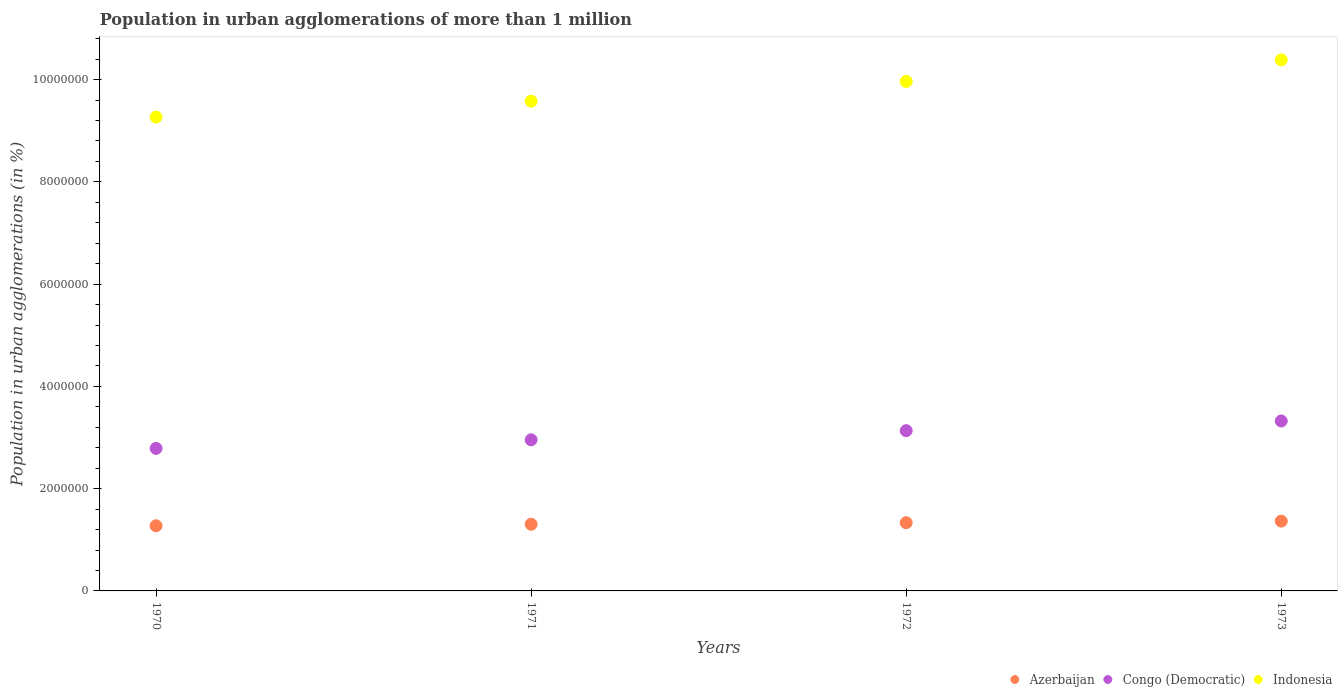What is the population in urban agglomerations in Congo (Democratic) in 1970?
Offer a terse response. 2.79e+06. Across all years, what is the maximum population in urban agglomerations in Indonesia?
Provide a short and direct response. 1.04e+07. Across all years, what is the minimum population in urban agglomerations in Congo (Democratic)?
Offer a very short reply. 2.79e+06. In which year was the population in urban agglomerations in Indonesia minimum?
Your response must be concise. 1970. What is the total population in urban agglomerations in Indonesia in the graph?
Ensure brevity in your answer.  3.92e+07. What is the difference between the population in urban agglomerations in Azerbaijan in 1971 and that in 1973?
Offer a terse response. -6.12e+04. What is the difference between the population in urban agglomerations in Congo (Democratic) in 1973 and the population in urban agglomerations in Indonesia in 1972?
Provide a short and direct response. -6.64e+06. What is the average population in urban agglomerations in Azerbaijan per year?
Offer a very short reply. 1.32e+06. In the year 1970, what is the difference between the population in urban agglomerations in Congo (Democratic) and population in urban agglomerations in Indonesia?
Keep it short and to the point. -6.48e+06. What is the ratio of the population in urban agglomerations in Azerbaijan in 1970 to that in 1973?
Your response must be concise. 0.93. Is the population in urban agglomerations in Azerbaijan in 1971 less than that in 1973?
Offer a very short reply. Yes. Is the difference between the population in urban agglomerations in Congo (Democratic) in 1971 and 1973 greater than the difference between the population in urban agglomerations in Indonesia in 1971 and 1973?
Your answer should be very brief. Yes. What is the difference between the highest and the second highest population in urban agglomerations in Indonesia?
Your response must be concise. 4.23e+05. What is the difference between the highest and the lowest population in urban agglomerations in Congo (Democratic)?
Make the answer very short. 5.36e+05. In how many years, is the population in urban agglomerations in Congo (Democratic) greater than the average population in urban agglomerations in Congo (Democratic) taken over all years?
Make the answer very short. 2. Is the sum of the population in urban agglomerations in Congo (Democratic) in 1971 and 1972 greater than the maximum population in urban agglomerations in Indonesia across all years?
Your answer should be very brief. No. Is it the case that in every year, the sum of the population in urban agglomerations in Azerbaijan and population in urban agglomerations in Indonesia  is greater than the population in urban agglomerations in Congo (Democratic)?
Your response must be concise. Yes. Does the population in urban agglomerations in Azerbaijan monotonically increase over the years?
Provide a short and direct response. Yes. How many dotlines are there?
Your response must be concise. 3. What is the difference between two consecutive major ticks on the Y-axis?
Make the answer very short. 2.00e+06. Does the graph contain grids?
Provide a succinct answer. No. How many legend labels are there?
Offer a very short reply. 3. How are the legend labels stacked?
Offer a very short reply. Horizontal. What is the title of the graph?
Your response must be concise. Population in urban agglomerations of more than 1 million. Does "Barbados" appear as one of the legend labels in the graph?
Ensure brevity in your answer.  No. What is the label or title of the Y-axis?
Your answer should be very brief. Population in urban agglomerations (in %). What is the Population in urban agglomerations (in %) of Azerbaijan in 1970?
Offer a terse response. 1.27e+06. What is the Population in urban agglomerations (in %) of Congo (Democratic) in 1970?
Offer a terse response. 2.79e+06. What is the Population in urban agglomerations (in %) in Indonesia in 1970?
Ensure brevity in your answer.  9.27e+06. What is the Population in urban agglomerations (in %) in Azerbaijan in 1971?
Offer a very short reply. 1.30e+06. What is the Population in urban agglomerations (in %) in Congo (Democratic) in 1971?
Offer a terse response. 2.96e+06. What is the Population in urban agglomerations (in %) of Indonesia in 1971?
Offer a very short reply. 9.58e+06. What is the Population in urban agglomerations (in %) of Azerbaijan in 1972?
Your answer should be very brief. 1.33e+06. What is the Population in urban agglomerations (in %) of Congo (Democratic) in 1972?
Your answer should be compact. 3.13e+06. What is the Population in urban agglomerations (in %) of Indonesia in 1972?
Make the answer very short. 9.96e+06. What is the Population in urban agglomerations (in %) of Azerbaijan in 1973?
Your answer should be very brief. 1.37e+06. What is the Population in urban agglomerations (in %) of Congo (Democratic) in 1973?
Offer a terse response. 3.32e+06. What is the Population in urban agglomerations (in %) in Indonesia in 1973?
Your answer should be very brief. 1.04e+07. Across all years, what is the maximum Population in urban agglomerations (in %) in Azerbaijan?
Provide a succinct answer. 1.37e+06. Across all years, what is the maximum Population in urban agglomerations (in %) of Congo (Democratic)?
Make the answer very short. 3.32e+06. Across all years, what is the maximum Population in urban agglomerations (in %) in Indonesia?
Offer a very short reply. 1.04e+07. Across all years, what is the minimum Population in urban agglomerations (in %) in Azerbaijan?
Give a very brief answer. 1.27e+06. Across all years, what is the minimum Population in urban agglomerations (in %) of Congo (Democratic)?
Give a very brief answer. 2.79e+06. Across all years, what is the minimum Population in urban agglomerations (in %) in Indonesia?
Offer a very short reply. 9.27e+06. What is the total Population in urban agglomerations (in %) in Azerbaijan in the graph?
Your answer should be compact. 5.28e+06. What is the total Population in urban agglomerations (in %) in Congo (Democratic) in the graph?
Your answer should be very brief. 1.22e+07. What is the total Population in urban agglomerations (in %) of Indonesia in the graph?
Your response must be concise. 3.92e+07. What is the difference between the Population in urban agglomerations (in %) of Azerbaijan in 1970 and that in 1971?
Offer a terse response. -2.96e+04. What is the difference between the Population in urban agglomerations (in %) of Congo (Democratic) in 1970 and that in 1971?
Keep it short and to the point. -1.68e+05. What is the difference between the Population in urban agglomerations (in %) in Indonesia in 1970 and that in 1971?
Offer a very short reply. -3.10e+05. What is the difference between the Population in urban agglomerations (in %) in Azerbaijan in 1970 and that in 1972?
Provide a succinct answer. -5.98e+04. What is the difference between the Population in urban agglomerations (in %) in Congo (Democratic) in 1970 and that in 1972?
Keep it short and to the point. -3.47e+05. What is the difference between the Population in urban agglomerations (in %) of Indonesia in 1970 and that in 1972?
Provide a succinct answer. -6.96e+05. What is the difference between the Population in urban agglomerations (in %) of Azerbaijan in 1970 and that in 1973?
Your response must be concise. -9.07e+04. What is the difference between the Population in urban agglomerations (in %) in Congo (Democratic) in 1970 and that in 1973?
Keep it short and to the point. -5.36e+05. What is the difference between the Population in urban agglomerations (in %) in Indonesia in 1970 and that in 1973?
Give a very brief answer. -1.12e+06. What is the difference between the Population in urban agglomerations (in %) in Azerbaijan in 1971 and that in 1972?
Offer a terse response. -3.03e+04. What is the difference between the Population in urban agglomerations (in %) in Congo (Democratic) in 1971 and that in 1972?
Your response must be concise. -1.79e+05. What is the difference between the Population in urban agglomerations (in %) of Indonesia in 1971 and that in 1972?
Your response must be concise. -3.86e+05. What is the difference between the Population in urban agglomerations (in %) of Azerbaijan in 1971 and that in 1973?
Ensure brevity in your answer.  -6.12e+04. What is the difference between the Population in urban agglomerations (in %) in Congo (Democratic) in 1971 and that in 1973?
Keep it short and to the point. -3.68e+05. What is the difference between the Population in urban agglomerations (in %) in Indonesia in 1971 and that in 1973?
Offer a terse response. -8.09e+05. What is the difference between the Population in urban agglomerations (in %) of Azerbaijan in 1972 and that in 1973?
Give a very brief answer. -3.09e+04. What is the difference between the Population in urban agglomerations (in %) in Congo (Democratic) in 1972 and that in 1973?
Your answer should be compact. -1.89e+05. What is the difference between the Population in urban agglomerations (in %) in Indonesia in 1972 and that in 1973?
Offer a very short reply. -4.23e+05. What is the difference between the Population in urban agglomerations (in %) of Azerbaijan in 1970 and the Population in urban agglomerations (in %) of Congo (Democratic) in 1971?
Offer a terse response. -1.68e+06. What is the difference between the Population in urban agglomerations (in %) in Azerbaijan in 1970 and the Population in urban agglomerations (in %) in Indonesia in 1971?
Provide a short and direct response. -8.30e+06. What is the difference between the Population in urban agglomerations (in %) in Congo (Democratic) in 1970 and the Population in urban agglomerations (in %) in Indonesia in 1971?
Provide a short and direct response. -6.79e+06. What is the difference between the Population in urban agglomerations (in %) in Azerbaijan in 1970 and the Population in urban agglomerations (in %) in Congo (Democratic) in 1972?
Offer a terse response. -1.86e+06. What is the difference between the Population in urban agglomerations (in %) of Azerbaijan in 1970 and the Population in urban agglomerations (in %) of Indonesia in 1972?
Give a very brief answer. -8.69e+06. What is the difference between the Population in urban agglomerations (in %) of Congo (Democratic) in 1970 and the Population in urban agglomerations (in %) of Indonesia in 1972?
Offer a very short reply. -7.18e+06. What is the difference between the Population in urban agglomerations (in %) in Azerbaijan in 1970 and the Population in urban agglomerations (in %) in Congo (Democratic) in 1973?
Provide a succinct answer. -2.05e+06. What is the difference between the Population in urban agglomerations (in %) of Azerbaijan in 1970 and the Population in urban agglomerations (in %) of Indonesia in 1973?
Offer a very short reply. -9.11e+06. What is the difference between the Population in urban agglomerations (in %) of Congo (Democratic) in 1970 and the Population in urban agglomerations (in %) of Indonesia in 1973?
Offer a terse response. -7.60e+06. What is the difference between the Population in urban agglomerations (in %) of Azerbaijan in 1971 and the Population in urban agglomerations (in %) of Congo (Democratic) in 1972?
Offer a terse response. -1.83e+06. What is the difference between the Population in urban agglomerations (in %) in Azerbaijan in 1971 and the Population in urban agglomerations (in %) in Indonesia in 1972?
Ensure brevity in your answer.  -8.66e+06. What is the difference between the Population in urban agglomerations (in %) of Congo (Democratic) in 1971 and the Population in urban agglomerations (in %) of Indonesia in 1972?
Provide a short and direct response. -7.01e+06. What is the difference between the Population in urban agglomerations (in %) in Azerbaijan in 1971 and the Population in urban agglomerations (in %) in Congo (Democratic) in 1973?
Give a very brief answer. -2.02e+06. What is the difference between the Population in urban agglomerations (in %) in Azerbaijan in 1971 and the Population in urban agglomerations (in %) in Indonesia in 1973?
Keep it short and to the point. -9.08e+06. What is the difference between the Population in urban agglomerations (in %) of Congo (Democratic) in 1971 and the Population in urban agglomerations (in %) of Indonesia in 1973?
Provide a short and direct response. -7.43e+06. What is the difference between the Population in urban agglomerations (in %) of Azerbaijan in 1972 and the Population in urban agglomerations (in %) of Congo (Democratic) in 1973?
Your answer should be compact. -1.99e+06. What is the difference between the Population in urban agglomerations (in %) of Azerbaijan in 1972 and the Population in urban agglomerations (in %) of Indonesia in 1973?
Keep it short and to the point. -9.05e+06. What is the difference between the Population in urban agglomerations (in %) of Congo (Democratic) in 1972 and the Population in urban agglomerations (in %) of Indonesia in 1973?
Make the answer very short. -7.25e+06. What is the average Population in urban agglomerations (in %) in Azerbaijan per year?
Provide a succinct answer. 1.32e+06. What is the average Population in urban agglomerations (in %) in Congo (Democratic) per year?
Make the answer very short. 3.05e+06. What is the average Population in urban agglomerations (in %) of Indonesia per year?
Your answer should be very brief. 9.80e+06. In the year 1970, what is the difference between the Population in urban agglomerations (in %) of Azerbaijan and Population in urban agglomerations (in %) of Congo (Democratic)?
Give a very brief answer. -1.51e+06. In the year 1970, what is the difference between the Population in urban agglomerations (in %) of Azerbaijan and Population in urban agglomerations (in %) of Indonesia?
Make the answer very short. -7.99e+06. In the year 1970, what is the difference between the Population in urban agglomerations (in %) in Congo (Democratic) and Population in urban agglomerations (in %) in Indonesia?
Provide a succinct answer. -6.48e+06. In the year 1971, what is the difference between the Population in urban agglomerations (in %) in Azerbaijan and Population in urban agglomerations (in %) in Congo (Democratic)?
Offer a very short reply. -1.65e+06. In the year 1971, what is the difference between the Population in urban agglomerations (in %) in Azerbaijan and Population in urban agglomerations (in %) in Indonesia?
Give a very brief answer. -8.27e+06. In the year 1971, what is the difference between the Population in urban agglomerations (in %) in Congo (Democratic) and Population in urban agglomerations (in %) in Indonesia?
Keep it short and to the point. -6.62e+06. In the year 1972, what is the difference between the Population in urban agglomerations (in %) of Azerbaijan and Population in urban agglomerations (in %) of Congo (Democratic)?
Keep it short and to the point. -1.80e+06. In the year 1972, what is the difference between the Population in urban agglomerations (in %) of Azerbaijan and Population in urban agglomerations (in %) of Indonesia?
Your answer should be very brief. -8.63e+06. In the year 1972, what is the difference between the Population in urban agglomerations (in %) of Congo (Democratic) and Population in urban agglomerations (in %) of Indonesia?
Provide a succinct answer. -6.83e+06. In the year 1973, what is the difference between the Population in urban agglomerations (in %) of Azerbaijan and Population in urban agglomerations (in %) of Congo (Democratic)?
Offer a very short reply. -1.96e+06. In the year 1973, what is the difference between the Population in urban agglomerations (in %) in Azerbaijan and Population in urban agglomerations (in %) in Indonesia?
Provide a succinct answer. -9.02e+06. In the year 1973, what is the difference between the Population in urban agglomerations (in %) of Congo (Democratic) and Population in urban agglomerations (in %) of Indonesia?
Give a very brief answer. -7.06e+06. What is the ratio of the Population in urban agglomerations (in %) in Azerbaijan in 1970 to that in 1971?
Your answer should be very brief. 0.98. What is the ratio of the Population in urban agglomerations (in %) in Congo (Democratic) in 1970 to that in 1971?
Provide a short and direct response. 0.94. What is the ratio of the Population in urban agglomerations (in %) in Indonesia in 1970 to that in 1971?
Offer a terse response. 0.97. What is the ratio of the Population in urban agglomerations (in %) in Azerbaijan in 1970 to that in 1972?
Make the answer very short. 0.96. What is the ratio of the Population in urban agglomerations (in %) in Congo (Democratic) in 1970 to that in 1972?
Give a very brief answer. 0.89. What is the ratio of the Population in urban agglomerations (in %) in Indonesia in 1970 to that in 1972?
Provide a short and direct response. 0.93. What is the ratio of the Population in urban agglomerations (in %) in Azerbaijan in 1970 to that in 1973?
Your response must be concise. 0.93. What is the ratio of the Population in urban agglomerations (in %) of Congo (Democratic) in 1970 to that in 1973?
Your answer should be very brief. 0.84. What is the ratio of the Population in urban agglomerations (in %) in Indonesia in 1970 to that in 1973?
Your answer should be very brief. 0.89. What is the ratio of the Population in urban agglomerations (in %) in Azerbaijan in 1971 to that in 1972?
Offer a very short reply. 0.98. What is the ratio of the Population in urban agglomerations (in %) in Congo (Democratic) in 1971 to that in 1972?
Your response must be concise. 0.94. What is the ratio of the Population in urban agglomerations (in %) of Indonesia in 1971 to that in 1972?
Offer a terse response. 0.96. What is the ratio of the Population in urban agglomerations (in %) of Azerbaijan in 1971 to that in 1973?
Offer a very short reply. 0.96. What is the ratio of the Population in urban agglomerations (in %) of Congo (Democratic) in 1971 to that in 1973?
Your answer should be very brief. 0.89. What is the ratio of the Population in urban agglomerations (in %) in Indonesia in 1971 to that in 1973?
Keep it short and to the point. 0.92. What is the ratio of the Population in urban agglomerations (in %) of Azerbaijan in 1972 to that in 1973?
Ensure brevity in your answer.  0.98. What is the ratio of the Population in urban agglomerations (in %) of Congo (Democratic) in 1972 to that in 1973?
Your answer should be very brief. 0.94. What is the ratio of the Population in urban agglomerations (in %) of Indonesia in 1972 to that in 1973?
Your answer should be compact. 0.96. What is the difference between the highest and the second highest Population in urban agglomerations (in %) of Azerbaijan?
Offer a very short reply. 3.09e+04. What is the difference between the highest and the second highest Population in urban agglomerations (in %) of Congo (Democratic)?
Your answer should be very brief. 1.89e+05. What is the difference between the highest and the second highest Population in urban agglomerations (in %) in Indonesia?
Keep it short and to the point. 4.23e+05. What is the difference between the highest and the lowest Population in urban agglomerations (in %) of Azerbaijan?
Your response must be concise. 9.07e+04. What is the difference between the highest and the lowest Population in urban agglomerations (in %) in Congo (Democratic)?
Give a very brief answer. 5.36e+05. What is the difference between the highest and the lowest Population in urban agglomerations (in %) in Indonesia?
Your response must be concise. 1.12e+06. 